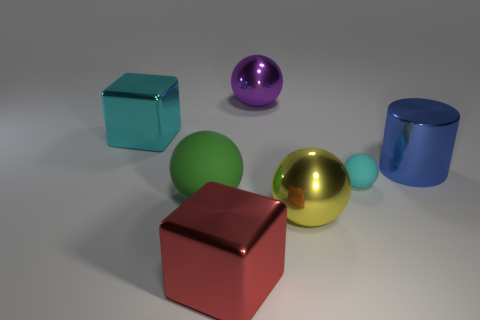Are there any patterns or symmetry in the arrangement of the objects? The arrangement does not display any clear patterns or symmetry. The objects are placed at varying distances from one another, with no discernible regular or mirrored layout. Each object stands alone with its distinct color and shape, contributing to a diverse but aesthetically pleasing collection. 